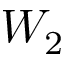Convert formula to latex. <formula><loc_0><loc_0><loc_500><loc_500>W _ { 2 }</formula> 